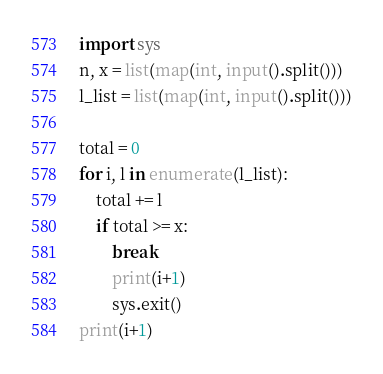<code> <loc_0><loc_0><loc_500><loc_500><_Python_>import sys
n, x = list(map(int, input().split()))
l_list = list(map(int, input().split()))

total = 0
for i, l in enumerate(l_list):
    total += l
    if total >= x:
        break
        print(i+1)
        sys.exit()
print(i+1)
</code> 